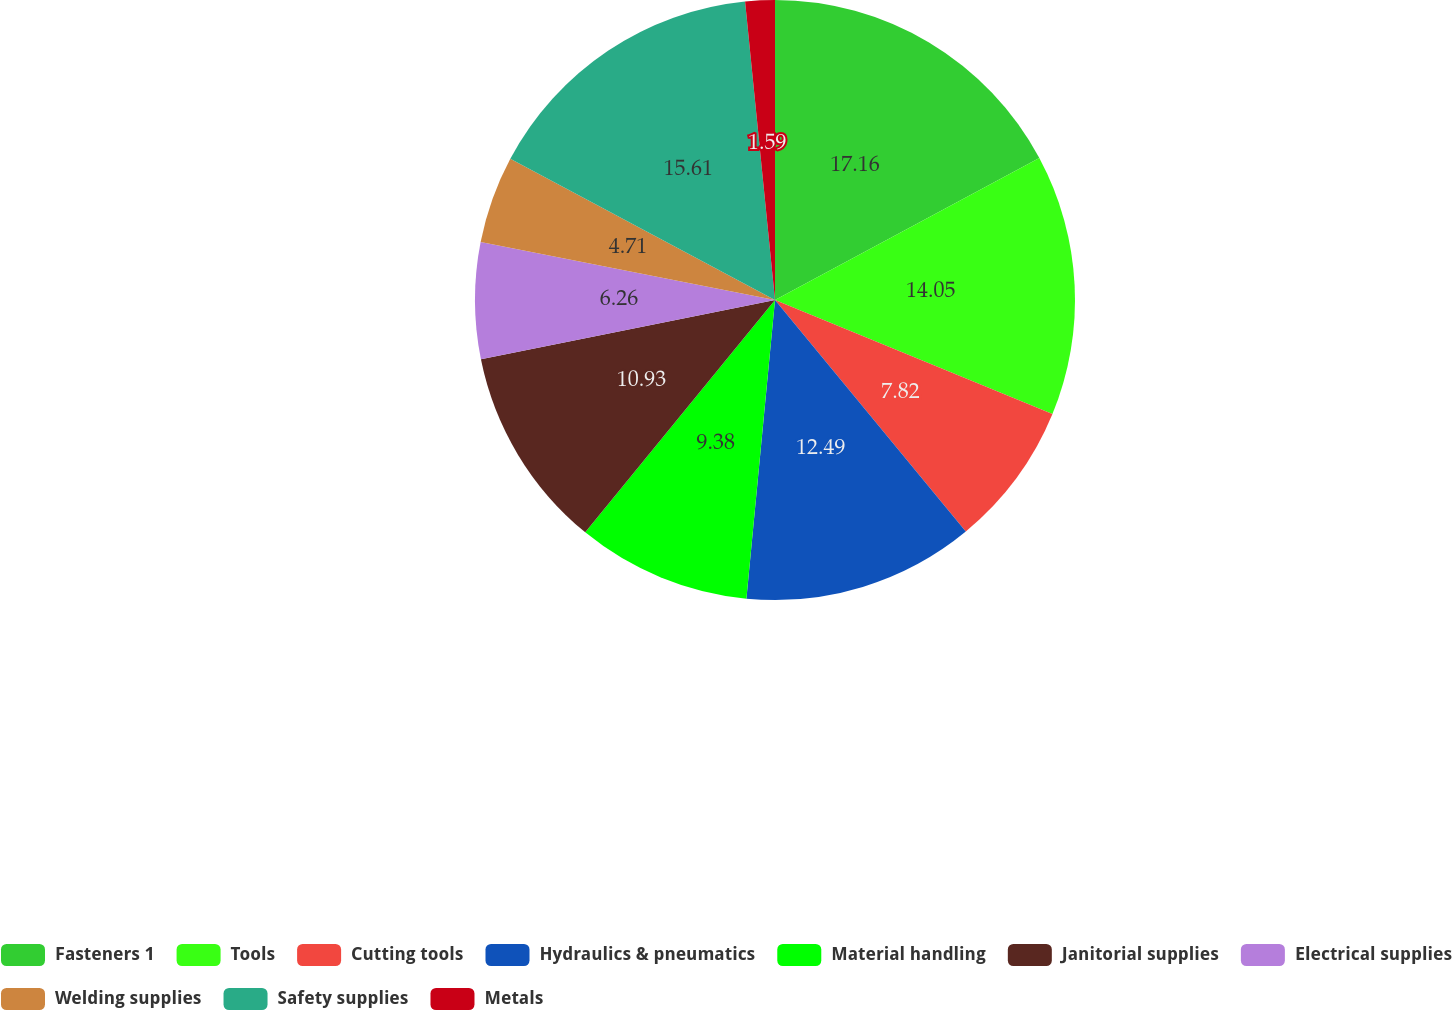<chart> <loc_0><loc_0><loc_500><loc_500><pie_chart><fcel>Fasteners 1<fcel>Tools<fcel>Cutting tools<fcel>Hydraulics & pneumatics<fcel>Material handling<fcel>Janitorial supplies<fcel>Electrical supplies<fcel>Welding supplies<fcel>Safety supplies<fcel>Metals<nl><fcel>17.16%<fcel>14.05%<fcel>7.82%<fcel>12.49%<fcel>9.38%<fcel>10.93%<fcel>6.26%<fcel>4.71%<fcel>15.61%<fcel>1.59%<nl></chart> 